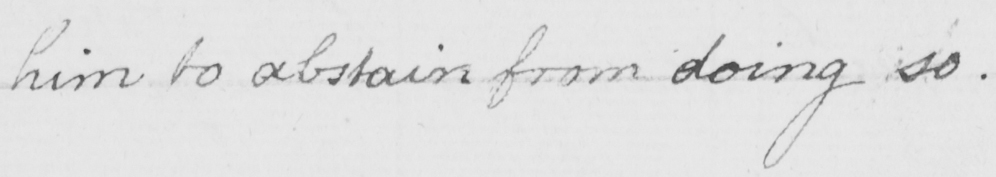Transcribe the text shown in this historical manuscript line. him to abstain from doing so . 